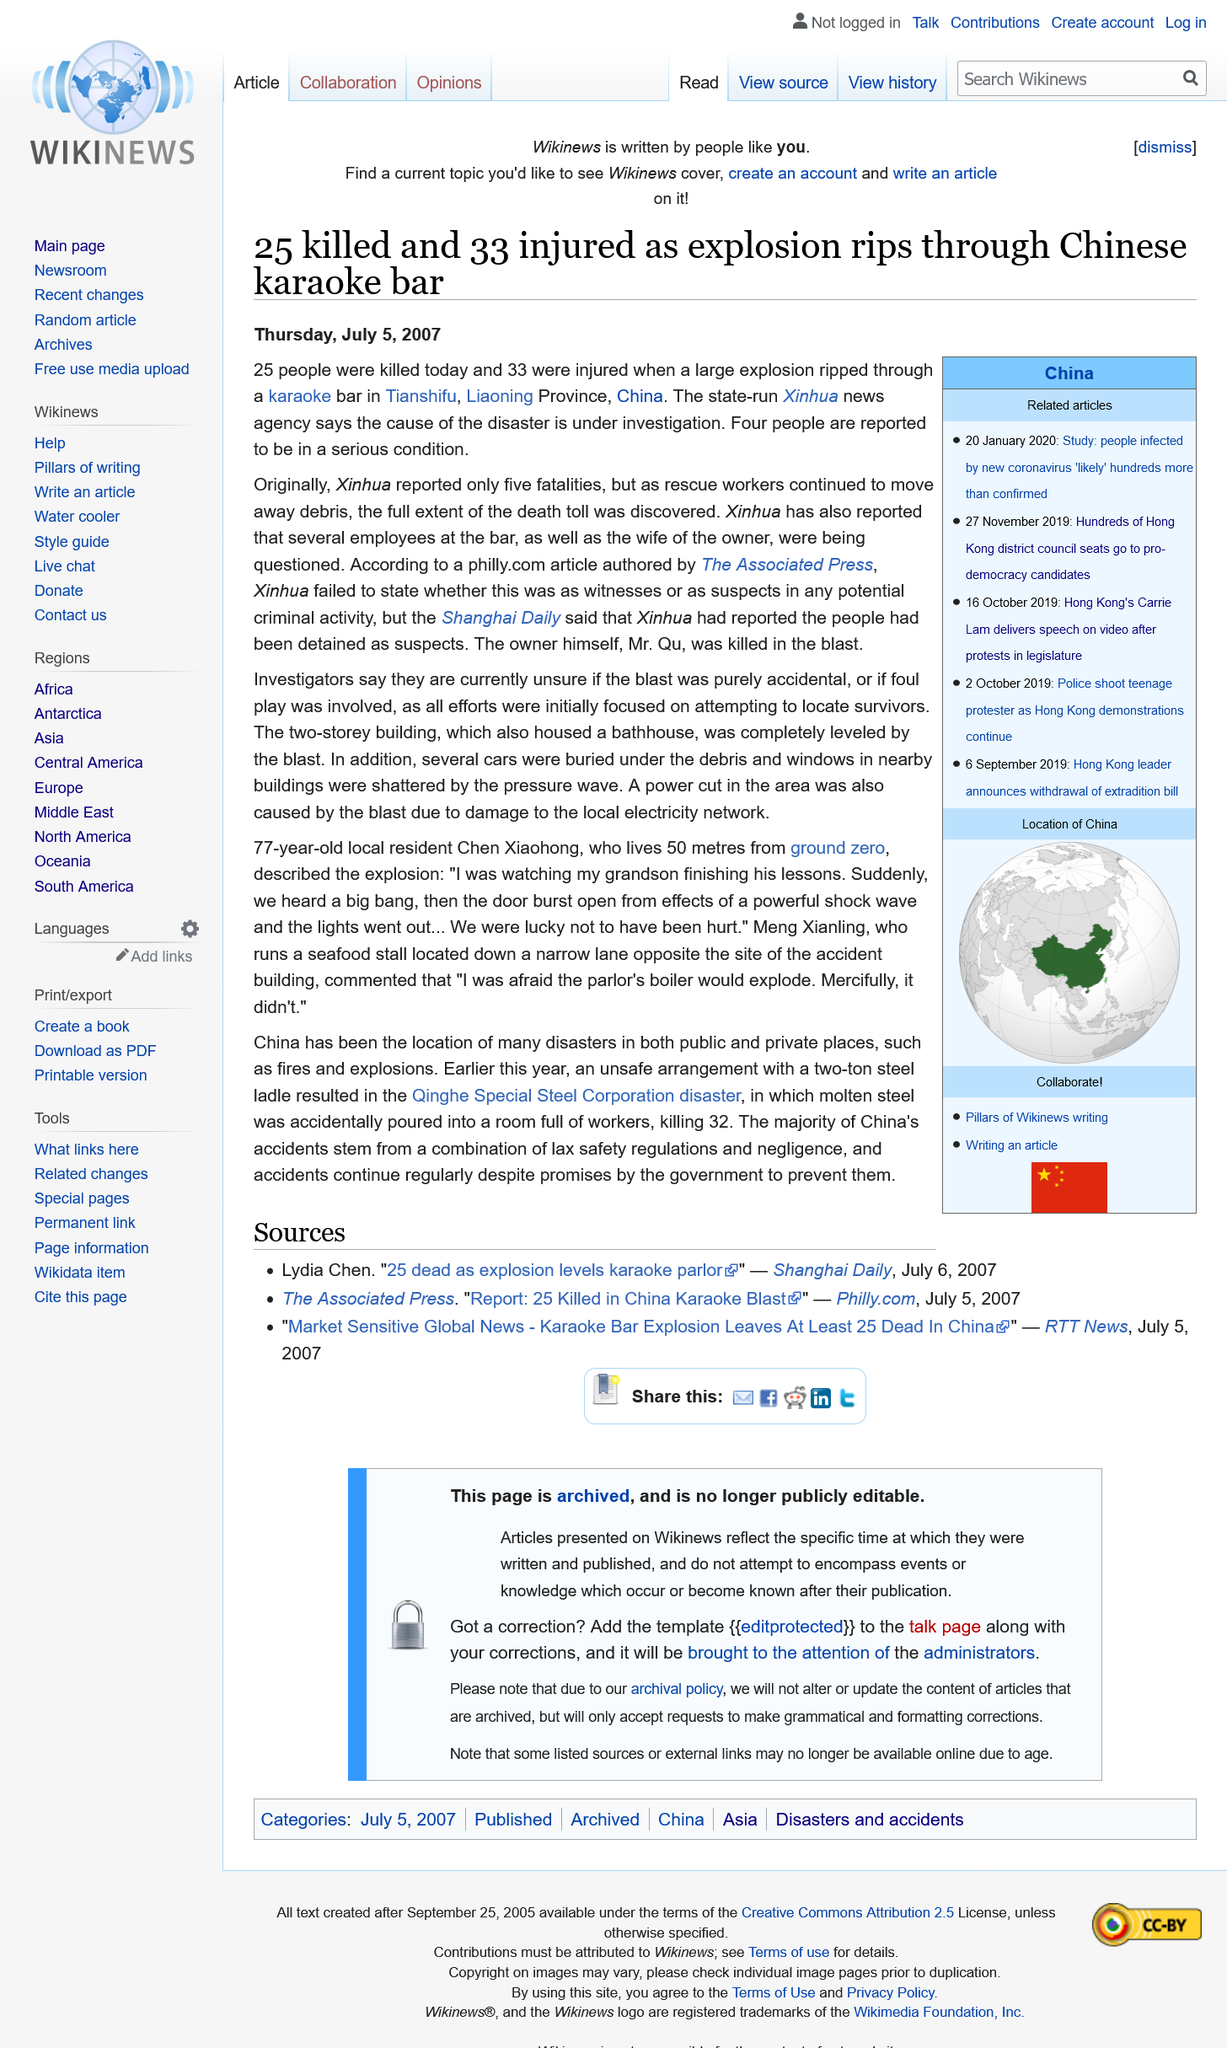Mention a couple of crucial points in this snapshot. The explosion completely destroyed the building where it occurred, causing extensive damage. On July 12, in Tianshifu, Liaoning Province, China, a karaoke bar was the scene of a devastating explosion. A total of 25 people were killed by the explosion. 